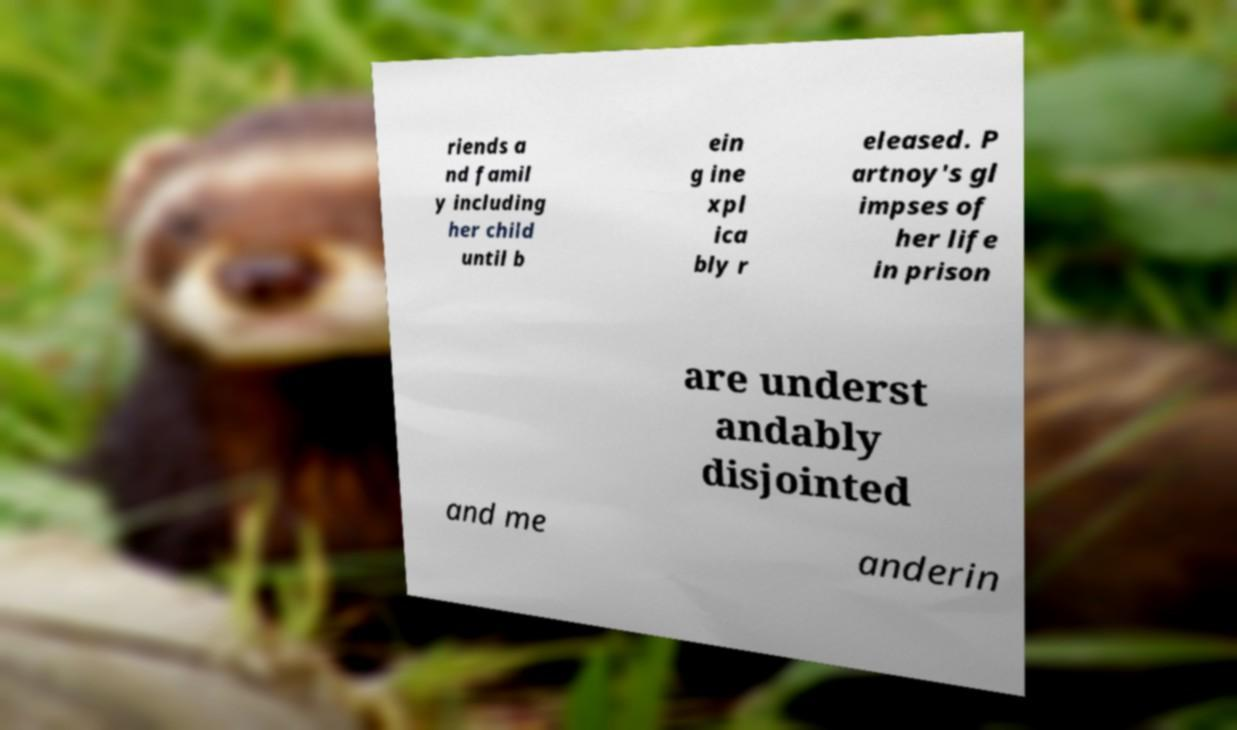For documentation purposes, I need the text within this image transcribed. Could you provide that? riends a nd famil y including her child until b ein g ine xpl ica bly r eleased. P artnoy's gl impses of her life in prison are underst andably disjointed and me anderin 